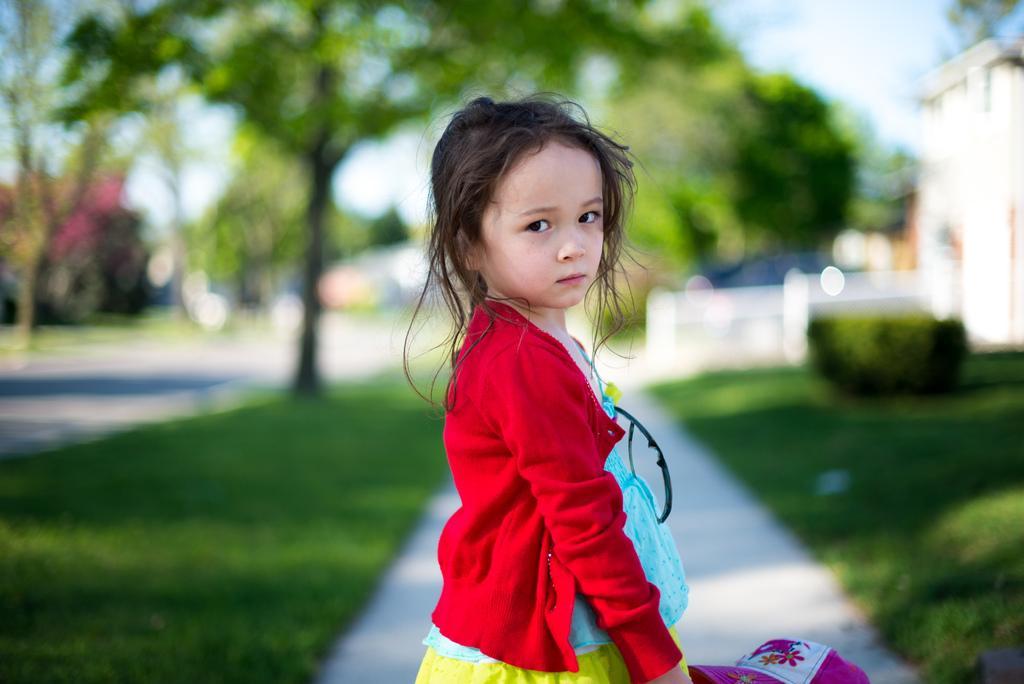In one or two sentences, can you explain what this image depicts? In this image a girl is standing on the path. She is holding a cap in her hand. Right side there is a building. Background there are few trees on the grassland. Left side there is a road. Top of the image there is sky. 